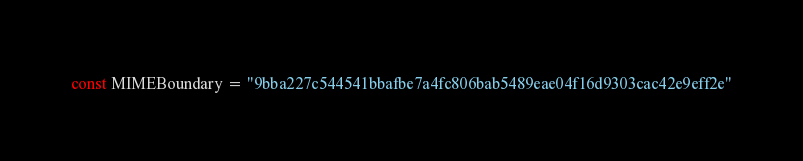<code> <loc_0><loc_0><loc_500><loc_500><_Go_>const MIMEBoundary = "9bba227c544541bbafbe7a4fc806bab5489eae04f16d9303cac42e9eff2e"
</code> 